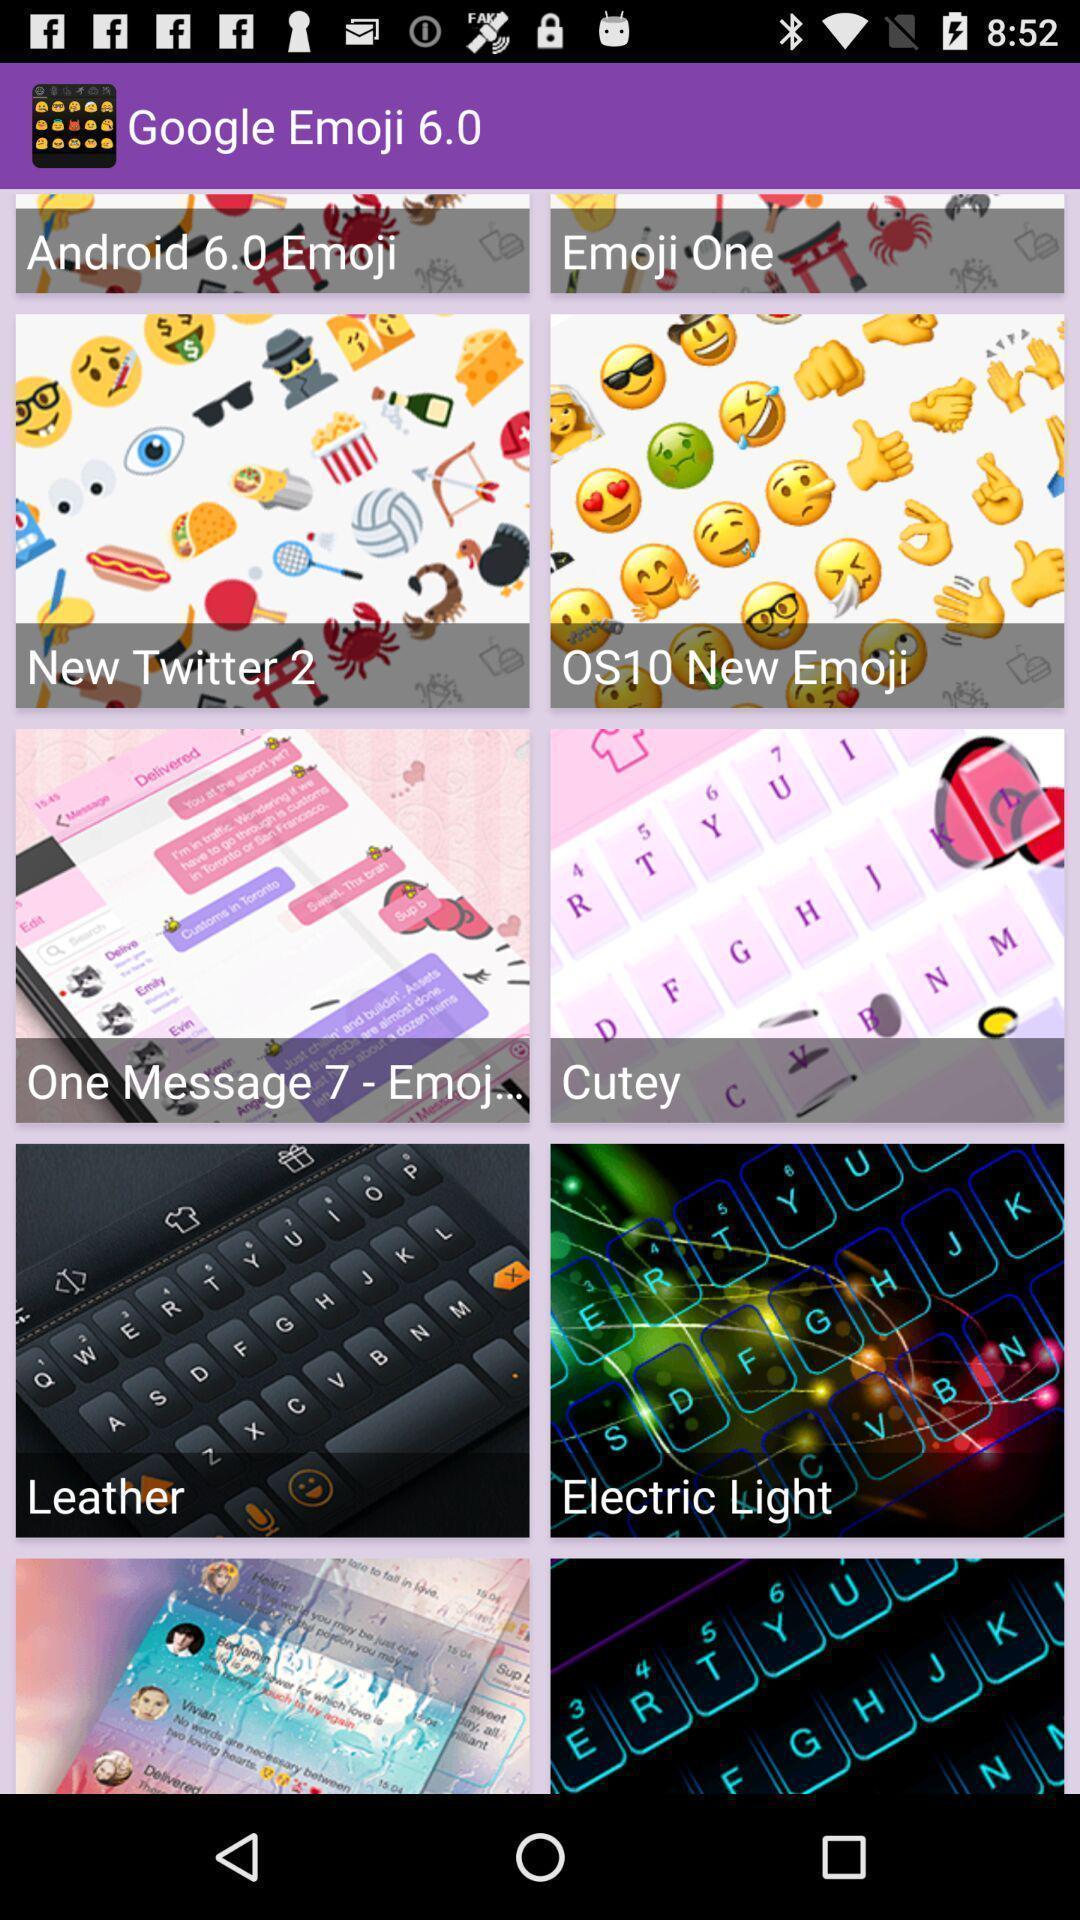Summarize the information in this screenshot. Page displaying with multiple images of emojis. 